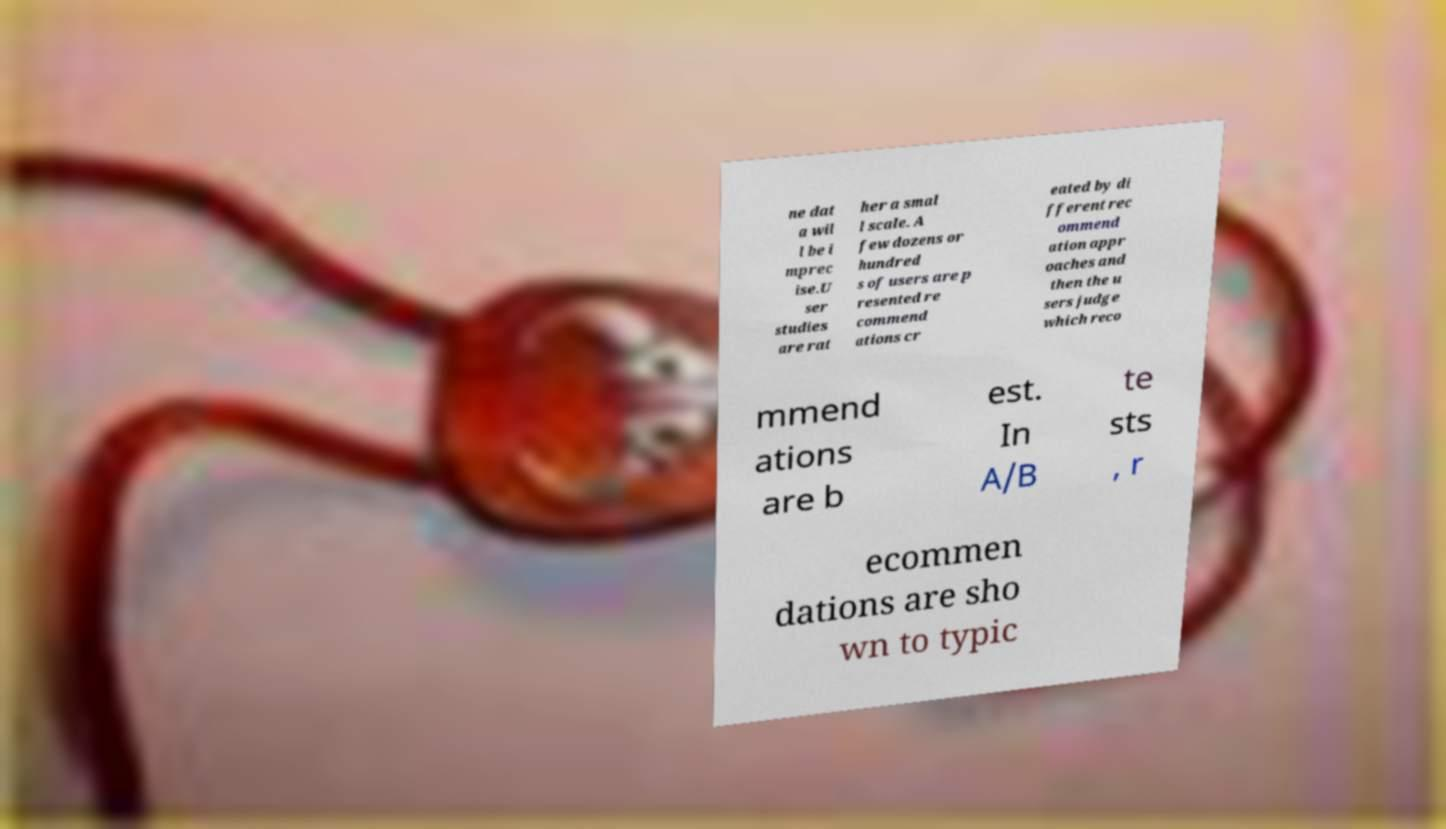Can you accurately transcribe the text from the provided image for me? ne dat a wil l be i mprec ise.U ser studies are rat her a smal l scale. A few dozens or hundred s of users are p resented re commend ations cr eated by di fferent rec ommend ation appr oaches and then the u sers judge which reco mmend ations are b est. In A/B te sts , r ecommen dations are sho wn to typic 